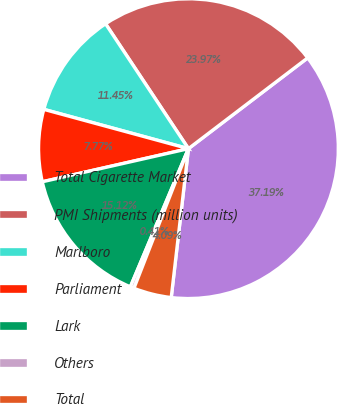Convert chart to OTSL. <chart><loc_0><loc_0><loc_500><loc_500><pie_chart><fcel>Total Cigarette Market<fcel>PMI Shipments (million units)<fcel>Marlboro<fcel>Parliament<fcel>Lark<fcel>Others<fcel>Total<nl><fcel>37.19%<fcel>23.97%<fcel>11.45%<fcel>7.77%<fcel>15.12%<fcel>0.41%<fcel>4.09%<nl></chart> 